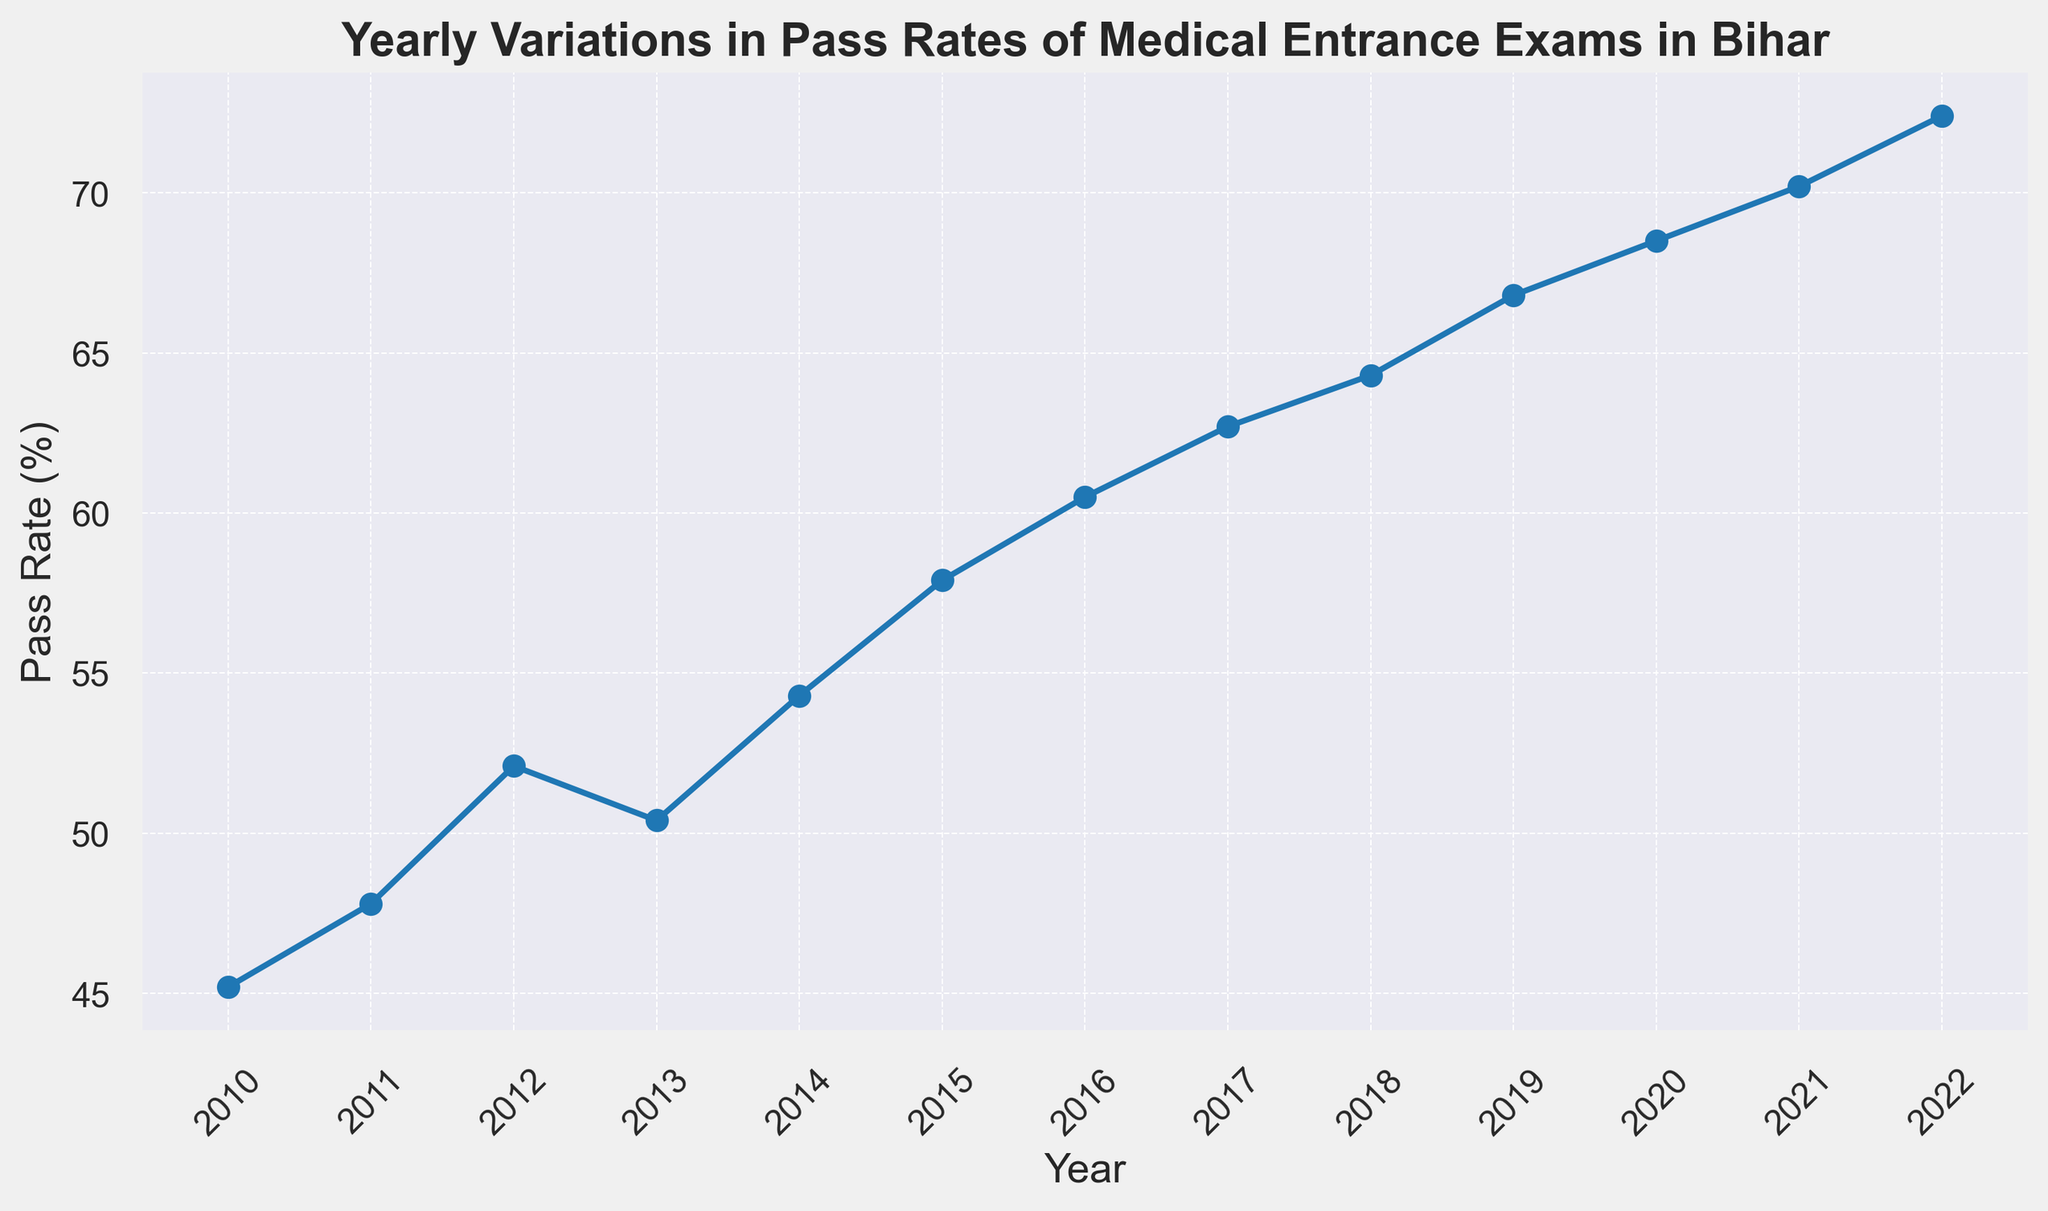What is the pass rate for the medical entrance exam in the year 2012? Locate the year 2012 on the x-axis and find the corresponding value on the y-axis, which is the pass rate.
Answer: 52.1% How did the pass rate change from 2014 to 2015? Identify the pass rates for 2014 and 2015, then calculate the difference (2015 - 2014) = (57.9 - 54.3).
Answer: Increased by 3.6% Which year had the highest pass rate for medical entrance exams? Observe the highest point on the y-axis and identify the corresponding year, which is 2022.
Answer: 2022 Compare the pass rates of 2013 and 2018. Which year had a higher pass rate, and by how much? Identify the pass rates for 2013 and 2018. Calculate the difference (64.3 - 50.4) to see which is higher and by how much.
Answer: 2018 by 13.9% What was the average pass rate from 2010 to 2013? Add the pass rates from 2010 to 2013 and then divide by the number of years involved: (45.2 + 47.8 + 52.1 + 50.4) / 4.
Answer: 48.875% How much did the pass rate increase from 2011 to 2022? Find the pass rates for 2011 and 2022. Subtract the pass rate in 2011 from the pass rate in 2022: (72.4 - 47.8).
Answer: 24.6% By how many percentage points did the pass rate increase between 2020 and 2022? Identify the pass rates for 2020 and 2022 and subtract the 2020 value from the 2022 value (72.4 - 68.5).
Answer: 3.9 percentage points What was the trend in pass rates from 2016 to 2020? Look at the years 2016 to 2020 on the x-axis and observe that the pass rates rose each year consistently.
Answer: Increasing trend Which year had the smallest increase in pass rate compared to the previous year? Calculate the year-to-year differences in pass rates and identify the smallest increase. The difference is smallest from 2013 to 2014 (54.3 - 50.4 = 3.9).
Answer: From 2013 to 2014 What is the average pass rate for the entire period from 2010 to 2022? Sum all the pass rates from 2010 to 2022 and divide by the number of years: (45.2 + 47.8 + 52.1 + 50.4 + 54.3 + 57.9 + 60.5 + 62.7 + 64.3 + 66.8 + 68.5 + 70.2 + 72.4) / 13.
Answer: 60.6846% 